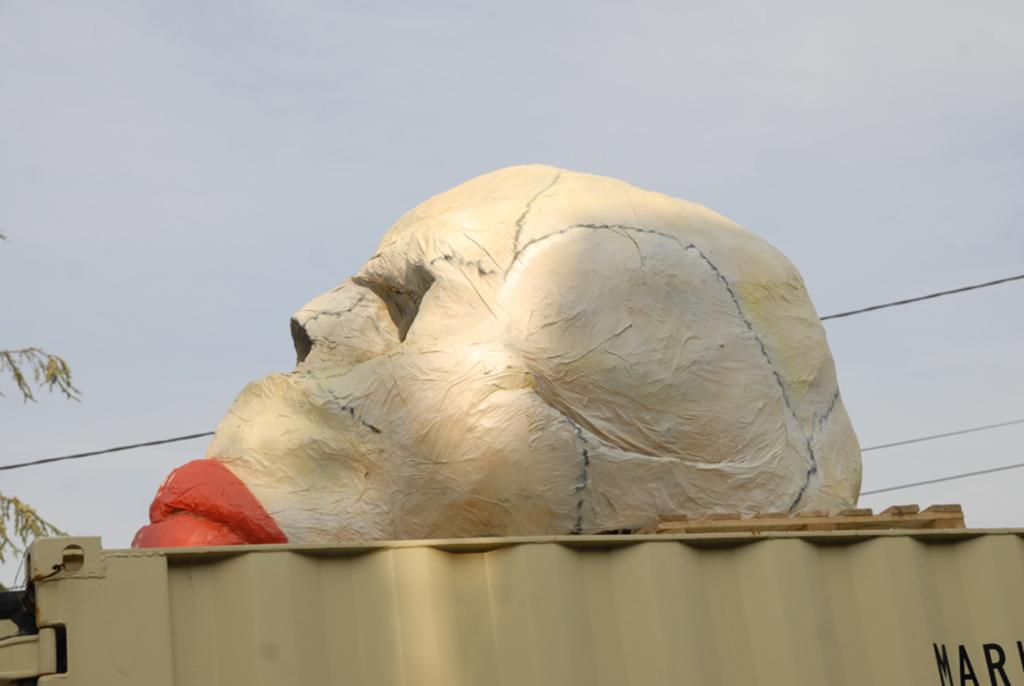What is the main subject of the image? There is a statue in the shape of a human skull in the image. What is the statue placed on? The statue is on an iron sheet. What can be seen at the top of the image? The sky is visible at the top of the image. What type of boot is being worn by the statue in the image? There is no boot present in the image, as the statue is in the shape of a human skull and does not have legs or feet. 